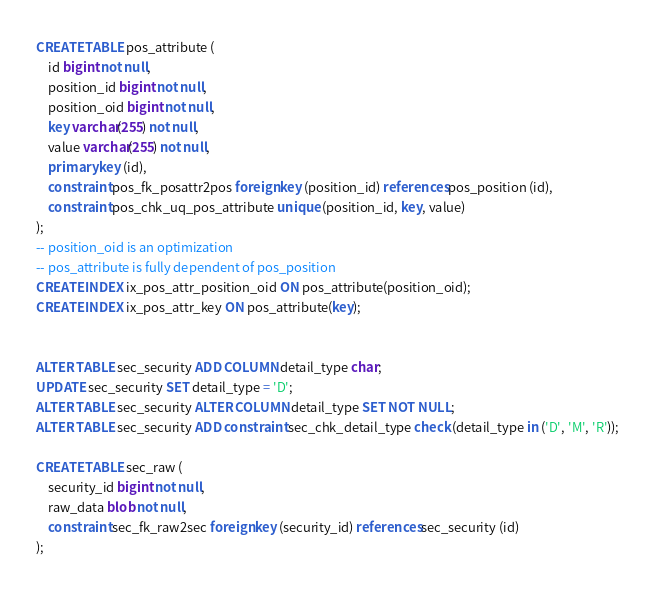Convert code to text. <code><loc_0><loc_0><loc_500><loc_500><_SQL_>CREATE TABLE pos_attribute (
    id bigint not null,
    position_id bigint not null,
    position_oid bigint not null,
    key varchar(255) not null,
    value varchar(255) not null,
    primary key (id),
    constraint pos_fk_posattr2pos foreign key (position_id) references pos_position (id),
    constraint pos_chk_uq_pos_attribute unique (position_id, key, value)
);
-- position_oid is an optimization
-- pos_attribute is fully dependent of pos_position
CREATE INDEX ix_pos_attr_position_oid ON pos_attribute(position_oid);
CREATE INDEX ix_pos_attr_key ON pos_attribute(key);


ALTER TABLE sec_security ADD COLUMN detail_type char;
UPDATE sec_security SET detail_type = 'D';
ALTER TABLE sec_security ALTER COLUMN detail_type SET NOT NULL;
ALTER TABLE sec_security ADD constraint sec_chk_detail_type check (detail_type in ('D', 'M', 'R'));

CREATE TABLE sec_raw (
    security_id bigint not null,
    raw_data blob not null,
    constraint sec_fk_raw2sec foreign key (security_id) references sec_security (id)
);</code> 